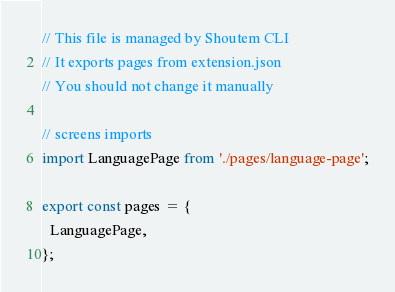Convert code to text. <code><loc_0><loc_0><loc_500><loc_500><_JavaScript_>// This file is managed by Shoutem CLI
// It exports pages from extension.json
// You should not change it manually

// screens imports
import LanguagePage from './pages/language-page';

export const pages = {
  LanguagePage,
};
</code> 